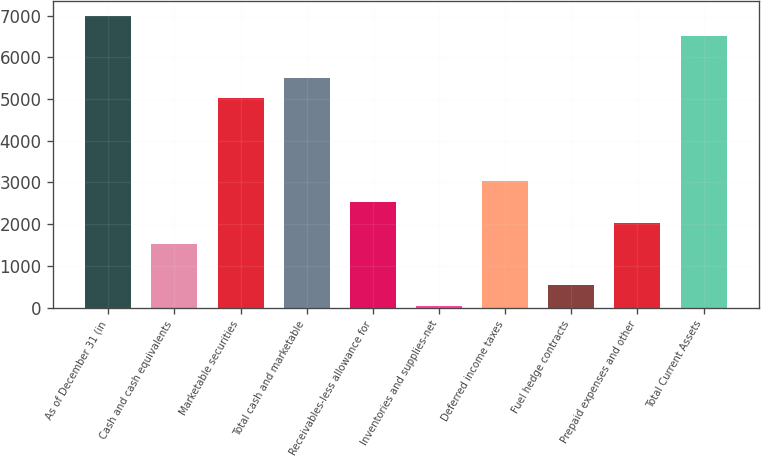Convert chart. <chart><loc_0><loc_0><loc_500><loc_500><bar_chart><fcel>As of December 31 (in<fcel>Cash and cash equivalents<fcel>Marketable securities<fcel>Total cash and marketable<fcel>Receivables-less allowance for<fcel>Inventories and supplies-net<fcel>Deferred income taxes<fcel>Fuel hedge contracts<fcel>Prepaid expenses and other<fcel>Total Current Assets<nl><fcel>7005.2<fcel>1536.55<fcel>5016.6<fcel>5513.75<fcel>2530.85<fcel>45.1<fcel>3028<fcel>542.25<fcel>2033.7<fcel>6508.05<nl></chart> 